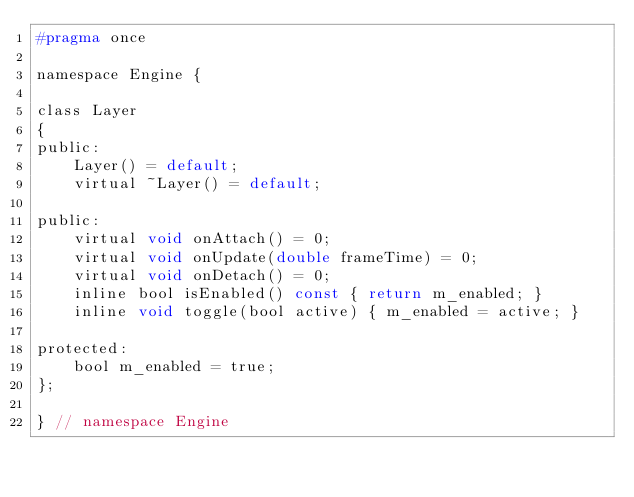<code> <loc_0><loc_0><loc_500><loc_500><_C_>#pragma once

namespace Engine {

class Layer
{
public:
    Layer() = default;
    virtual ~Layer() = default;

public:
    virtual void onAttach() = 0;
    virtual void onUpdate(double frameTime) = 0;
    virtual void onDetach() = 0;
    inline bool isEnabled() const { return m_enabled; }
    inline void toggle(bool active) { m_enabled = active; }

protected:
    bool m_enabled = true;
};

} // namespace Engine
</code> 